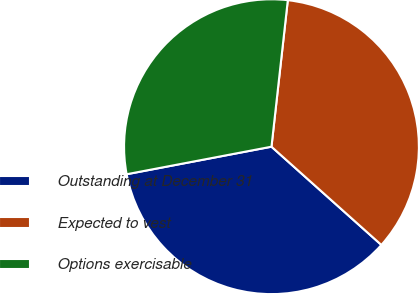<chart> <loc_0><loc_0><loc_500><loc_500><pie_chart><fcel>Outstanding at December 31<fcel>Expected to vest<fcel>Options exercisable<nl><fcel>35.4%<fcel>34.84%<fcel>29.76%<nl></chart> 